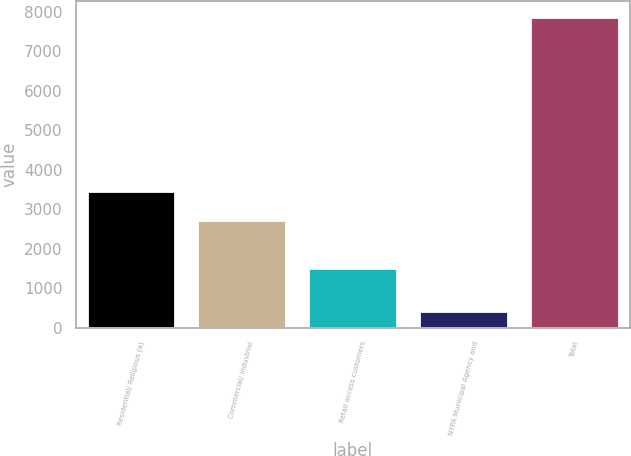Convert chart to OTSL. <chart><loc_0><loc_0><loc_500><loc_500><bar_chart><fcel>Residential/ Religious (a)<fcel>Commercial/ Industrial<fcel>Retail access customers<fcel>NYPA Municipal Agency and<fcel>Total<nl><fcel>3466.5<fcel>2720<fcel>1507<fcel>413<fcel>7878<nl></chart> 